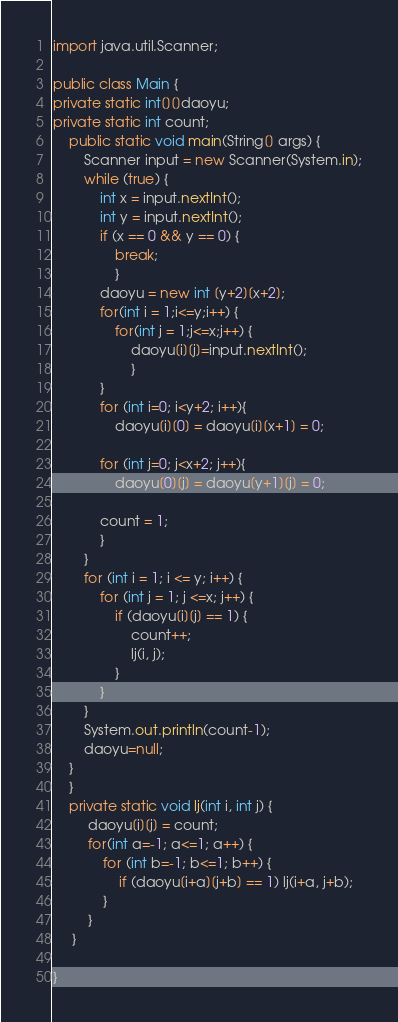Convert code to text. <code><loc_0><loc_0><loc_500><loc_500><_Java_>import java.util.Scanner;

public class Main {
private static int[][]daoyu;
private static int count;
    public static void main(String[] args) {
        Scanner input = new Scanner(System.in);
        while (true) {
            int x = input.nextInt();
            int y = input.nextInt();
            if (x == 0 && y == 0) {
            	break;
            	}
            daoyu = new int [y+2][x+2];
            for(int i = 1;i<=y;i++) {
            	for(int j = 1;j<=x;j++) {
            		daoyu[i][j]=input.nextInt();
            		}
            }
            for (int i=0; i<y+2; i++){
            	daoyu[i][0] = daoyu[i][x+1] = 0;
         
            for (int j=0; j<x+2; j++){
            	daoyu[0][j] = daoyu[y+1][j] = 0;
 
            count = 1;
            }
        }
        for (int i = 1; i <= y; i++) {
            for (int j = 1; j <=x; j++) {
                if (daoyu[i][j] == 1) {
                    count++;
                    lj(i, j);
                }
            }
        } 
        System.out.println(count-1);
        daoyu=null;
    }
    }
    private static void lj(int i, int j) {
    	 daoyu[i][j] = count;
         for(int a=-1; a<=1; a++) {
             for (int b=-1; b<=1; b++) {
                 if (daoyu[i+a][j+b] == 1) lj(i+a, j+b);
             }
         }
     }
 
}
</code> 